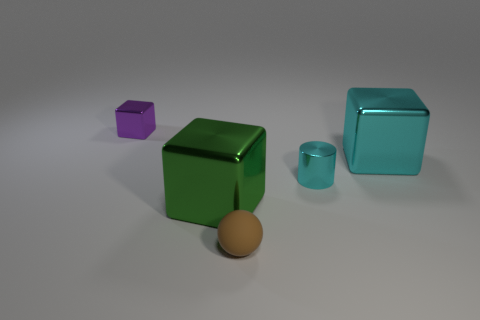Are there fewer purple cubes to the right of the cyan cylinder than small rubber spheres that are right of the brown ball?
Provide a short and direct response. No. What material is the thing that is the same color as the small shiny cylinder?
Offer a terse response. Metal. There is a metallic object in front of the small cyan thing; what color is it?
Your answer should be compact. Green. Is the small rubber thing the same color as the metallic cylinder?
Provide a short and direct response. No. There is a large object on the right side of the large thing left of the brown rubber object; what number of cylinders are right of it?
Provide a short and direct response. 0. What size is the cylinder?
Give a very brief answer. Small. There is a cube that is the same size as the green thing; what is it made of?
Provide a succinct answer. Metal. There is a tiny block; how many things are in front of it?
Provide a succinct answer. 4. Does the tiny thing that is right of the tiny rubber object have the same material as the large cube that is to the right of the green metallic thing?
Your response must be concise. Yes. What is the shape of the small metal thing that is behind the big metallic object that is on the right side of the small metal thing that is in front of the purple block?
Your response must be concise. Cube. 